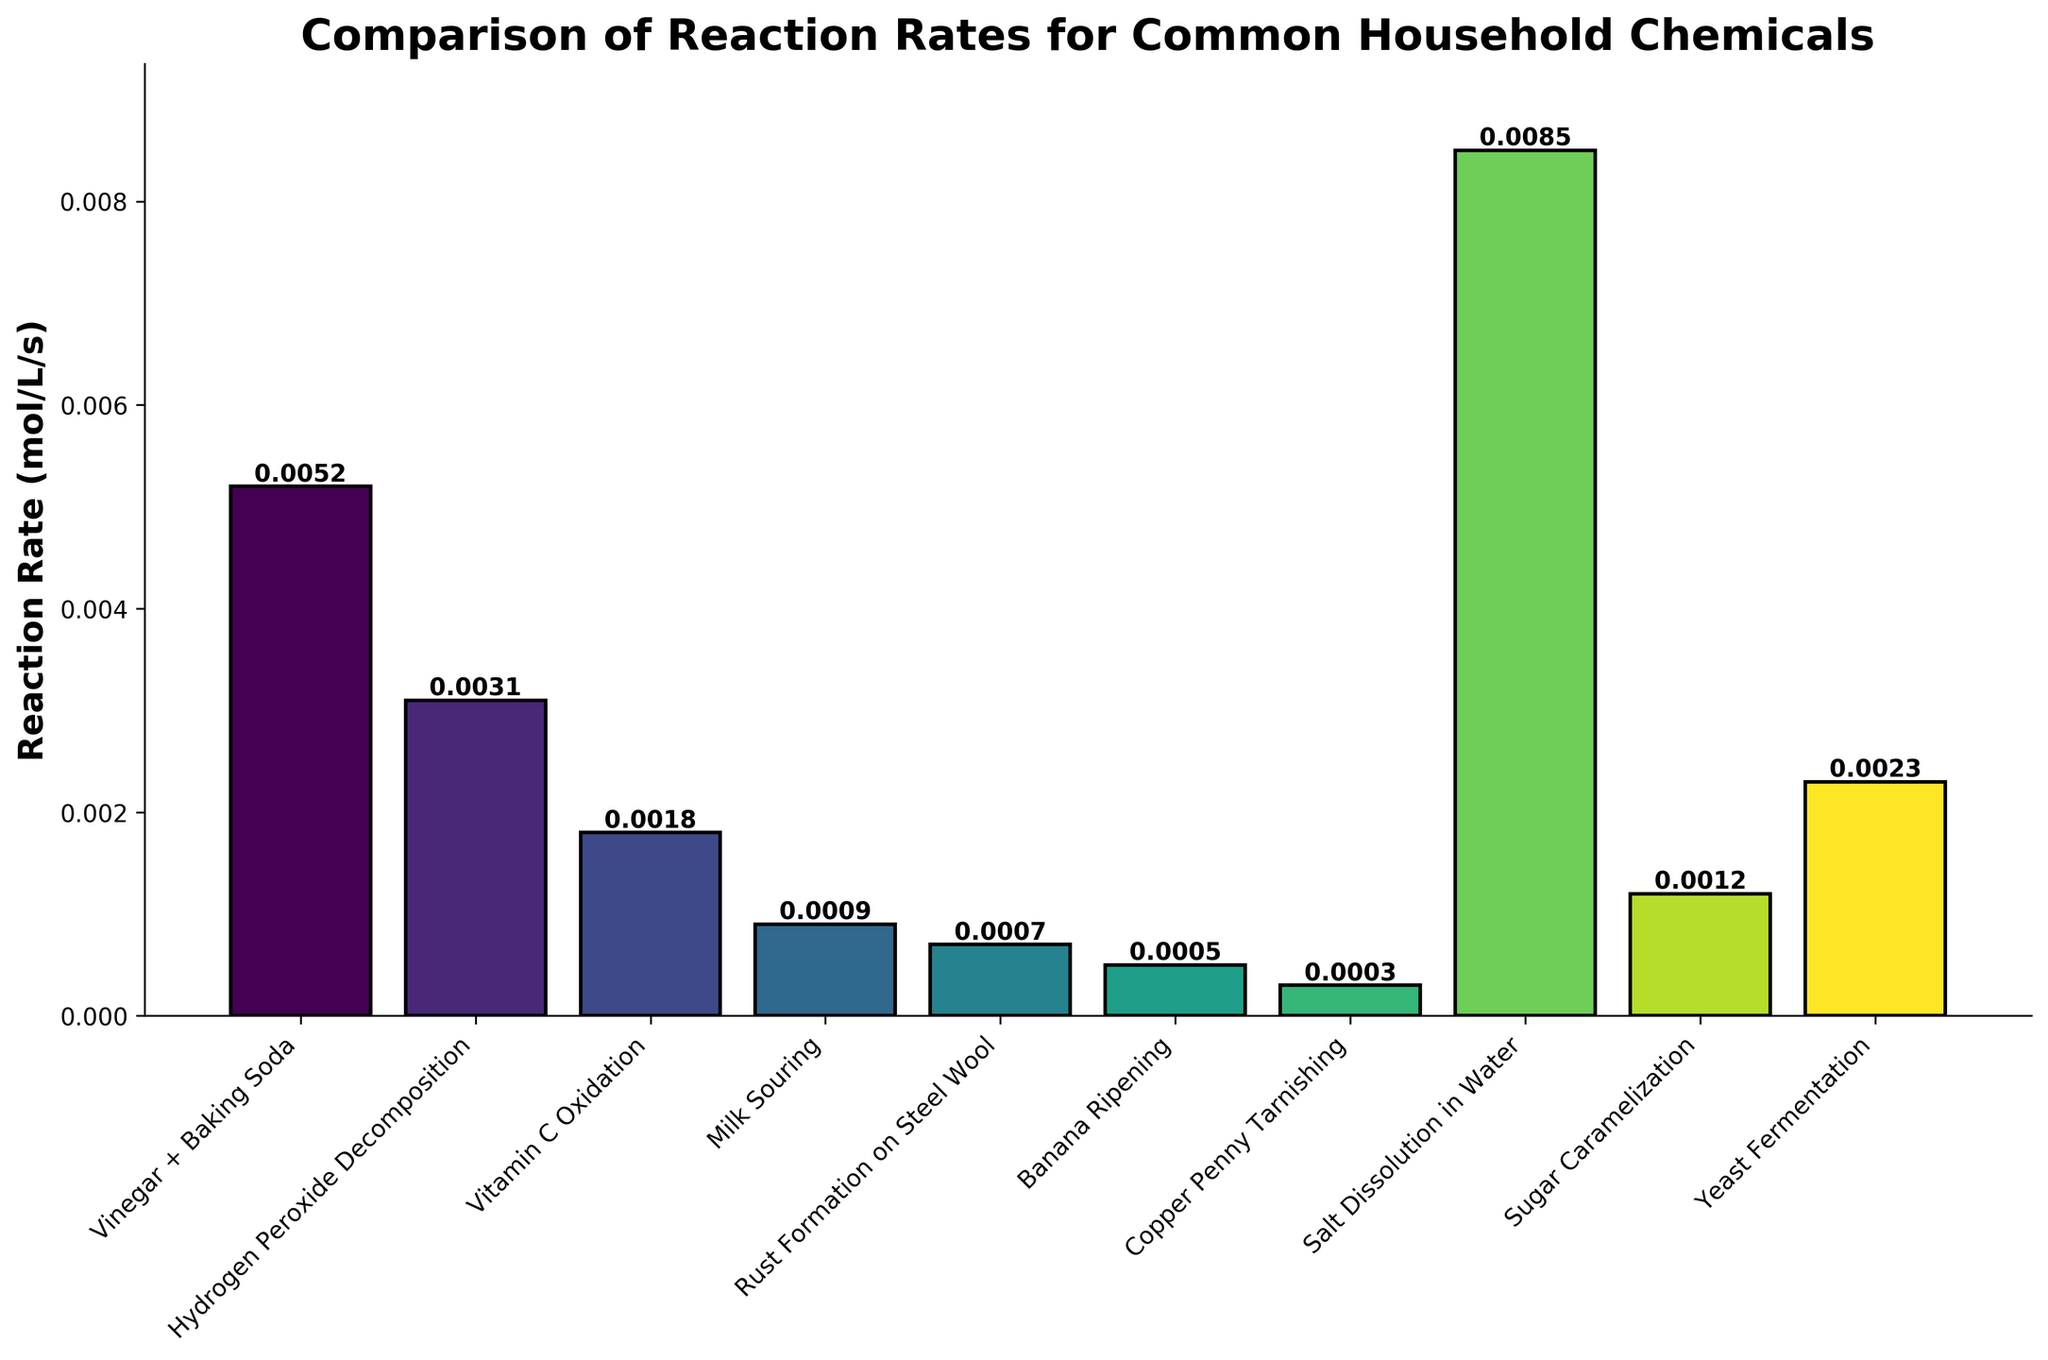What is the highest reaction rate observed in the figure? To find the highest reaction rate, identify the tallest bar in the chart. The bar representing 'Salt Dissolution in Water' is the tallest one, with a reaction rate of 0.0085 mol/L/s.
Answer: 0.0085 mol/L/s Which chemical has the lowest reaction rate? To determine the lowest reaction rate, identify the shortest bar in the plot. The shortest bar represents 'Copper Penny Tarnishing', with a reaction rate of 0.0003 mol/L/s.
Answer: Copper Penny Tarnishing Compare the reaction rates of 'Vinegar + Baking Soda' and 'Yeast Fermentation'. Which one is faster? Locate the bars for 'Vinegar + Baking Soda' and 'Yeast Fermentation'. The bar for 'Vinegar + Baking Soda' has a height of 0.0052 mol/L/s, whereas 'Yeast Fermentation' has a height of 0.0023 mol/L/s. Since 0.0052 is greater than 0.0023, the reaction rate of 'Vinegar + Baking Soda' is faster.
Answer: Vinegar + Baking Soda What is the average reaction rate of 'Milk Souring', 'Rust Formation on Steel Wool', and 'Banana Ripening'? Sum the reaction rates of 'Milk Souring' (0.0009), 'Rust Formation on Steel Wool' (0.0007), and 'Banana Ripening' (0.0005), which equals 0.0021. Then, divide by 3 to find the average: 0.0021 / 3 = 0.0007 mol/L/s.
Answer: 0.0007 mol/L/s What is the difference between the reaction rates of the fastest and slowest chemical reactions? Identify the fastest reaction, 'Salt Dissolution in Water' (0.0085 mol/L/s), and the slowest, 'Copper Penny Tarnishing' (0.0003 mol/L/s). Subtract the smallest from the largest: 0.0085 - 0.0003 = 0.0082 mol/L/s.
Answer: 0.0082 mol/L/s Which two reactions have the most similar reaction rates? Compare the heights of all bars visually and identify the ones that are closest in height. 'Milk Souring' and 'Rust Formation on Steel Wool' have reaction rates of 0.0009 mol/L/s and 0.0007 mol/L/s, respectively, which are the most similar rates.
Answer: Milk Souring and Rust Formation on Steel Wool What is the median reaction rate of all the chemicals listed? First, list the rates in ascending order: 0.0003, 0.0005, 0.0007, 0.0009, 0.0012, 0.0018, 0.0023, 0.0031, 0.0052, 0.0085. With 10 values, the median is the average of the 5th and 6th values. Sum 0.0012 and 0.0018 to get 0.003; then divide by 2: 0.003 / 2 = 0.0015 mol/L/s.
Answer: 0.0015 mol/L/s 